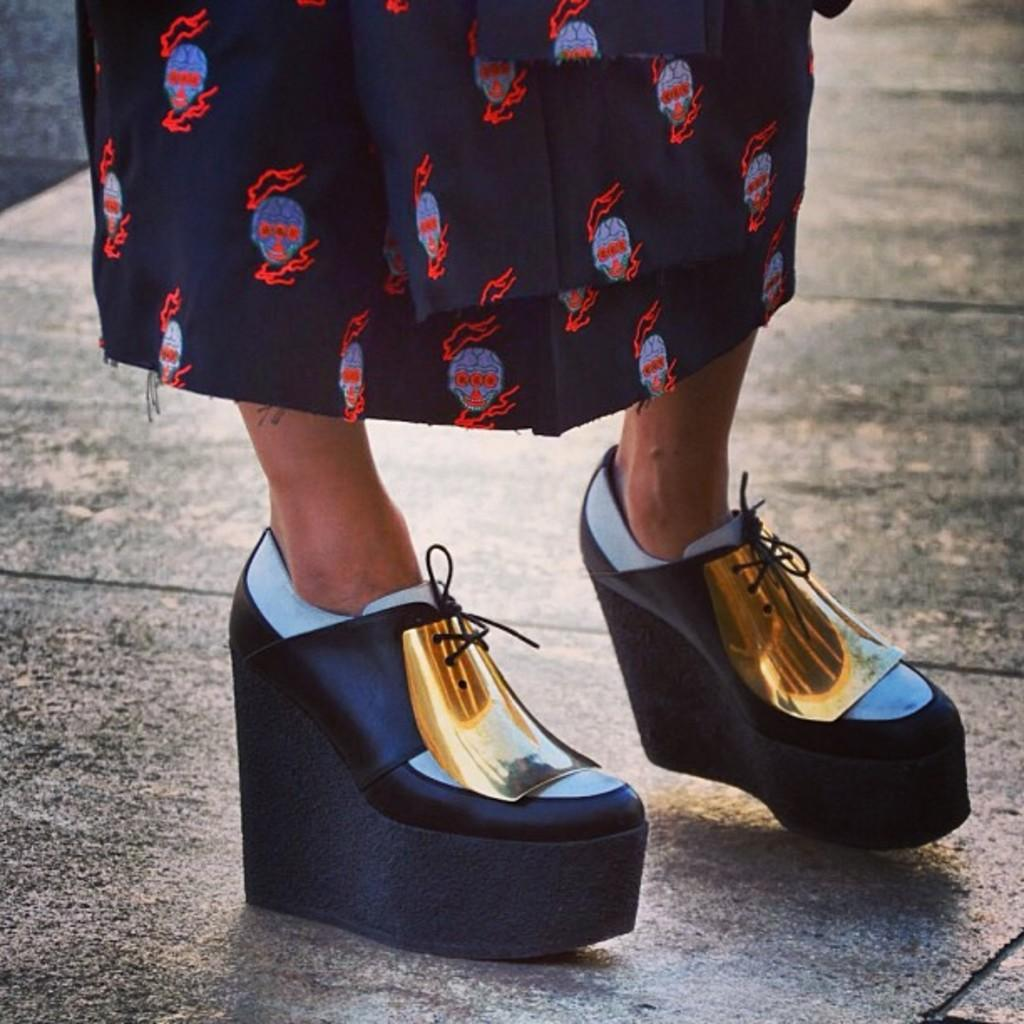Who or what is present in the image? There is a person in the image. What is the person doing in the image? The person is standing on a surface. What type of footwear is the person wearing? The person is wearing sandals. Is there a visible connection between the person and the ground in the image? There is no mention of a connection between the person and the ground in the image, but it can be inferred that the person is standing on the surface, which implies a connection. 